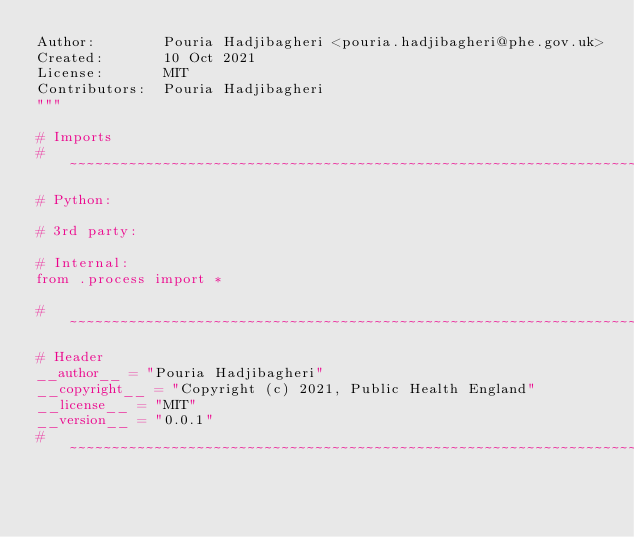Convert code to text. <code><loc_0><loc_0><loc_500><loc_500><_Python_>Author:        Pouria Hadjibagheri <pouria.hadjibagheri@phe.gov.uk>
Created:       10 Oct 2021
License:       MIT
Contributors:  Pouria Hadjibagheri
"""

# Imports
# ~~~~~~~~~~~~~~~~~~~~~~~~~~~~~~~~~~~~~~~~~~~~~~~~~~~~~~~~~~~~~~~~~~~~~~~~~~~~~~~~~~~~~~~~
# Python:

# 3rd party:

# Internal:
from .process import *

# ~~~~~~~~~~~~~~~~~~~~~~~~~~~~~~~~~~~~~~~~~~~~~~~~~~~~~~~~~~~~~~~~~~~~~~~~~~~~~~~~~~~~~~~~
# Header
__author__ = "Pouria Hadjibagheri"
__copyright__ = "Copyright (c) 2021, Public Health England"
__license__ = "MIT"
__version__ = "0.0.1"
# ~~~~~~~~~~~~~~~~~~~~~~~~~~~~~~~~~~~~~~~~~~~~~~~~~~~~~~~~~~~~~~~~~~~~~~~~~~~~~~~~~~~~~~~~
</code> 